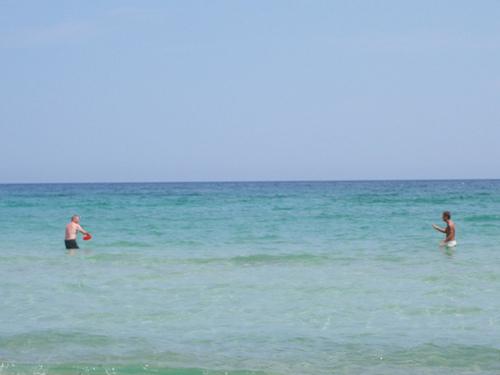How deep is the water on the shirtless man?
Answer briefly. Waist. Is it a warm day?
Short answer required. Yes. Is this a good day to go surfing?
Answer briefly. No. How many people are in the water?
Answer briefly. 2. What are the people riding on?
Keep it brief. Nothing. What is this guy holding?
Short answer required. Frisbee. Is that a man or woman on the right?
Quick response, please. Man. How many people are in this photo?
Be succinct. 2. Is this lake or ocean water?
Answer briefly. Ocean. Do you see a boat in the photo?
Quick response, please. No. What are the men playing?
Keep it brief. Frisbee. Are there 2 men in the water?
Write a very short answer. Yes. 